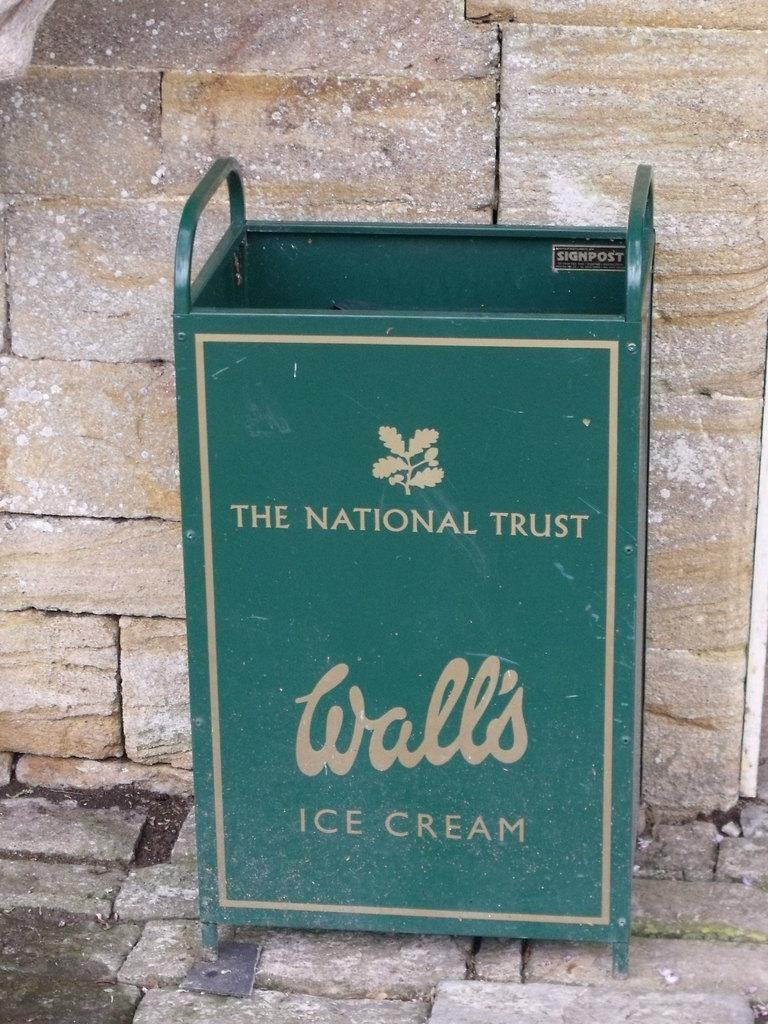<image>
Present a compact description of the photo's key features. The National Trust Wallis Ice Cream green stand 